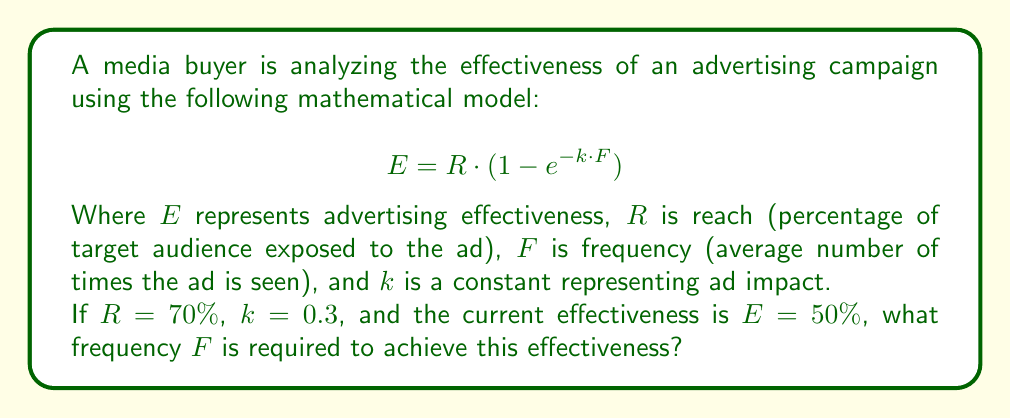Help me with this question. To solve this problem, we'll follow these steps:

1) We start with the given equation:
   $$E = R \cdot (1 - e^{-k \cdot F})$$

2) We know the following values:
   $E = 50\% = 0.5$
   $R = 70\% = 0.7$
   $k = 0.3$

3) Let's substitute these values into the equation:
   $$0.5 = 0.7 \cdot (1 - e^{-0.3 \cdot F})$$

4) Divide both sides by 0.7:
   $$\frac{0.5}{0.7} = 1 - e^{-0.3 \cdot F}$$

5) Simplify:
   $$0.7143 = 1 - e^{-0.3 \cdot F}$$

6) Subtract both sides from 1:
   $$0.2857 = e^{-0.3 \cdot F}$$

7) Take the natural logarithm of both sides:
   $$\ln(0.2857) = -0.3 \cdot F$$

8) Divide both sides by -0.3:
   $$\frac{\ln(0.2857)}{-0.3} = F$$

9) Calculate the result:
   $$F \approx 4.17$$

Therefore, a frequency of approximately 4.17 is required to achieve the given effectiveness.
Answer: $F \approx 4.17$ 